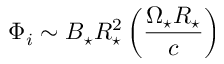<formula> <loc_0><loc_0><loc_500><loc_500>\Phi _ { i } \sim B _ { ^ { * } } R _ { ^ { * } } ^ { 2 } \left ( \frac { \Omega _ { ^ { * } } R _ { ^ { * } } } { c } \right )</formula> 